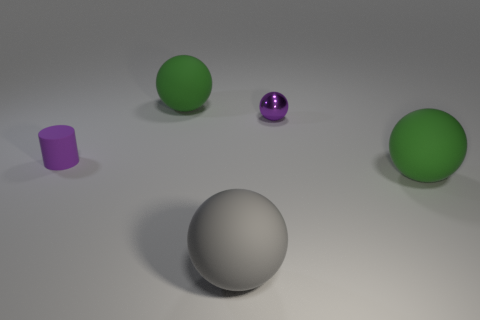Subtract all metal spheres. How many spheres are left? 3 Add 3 tiny purple matte things. How many objects exist? 8 Subtract all purple balls. How many balls are left? 3 Subtract all purple cylinders. How many green balls are left? 2 Subtract all cylinders. How many objects are left? 4 Subtract all blue cylinders. Subtract all yellow cubes. How many cylinders are left? 1 Subtract all big green matte blocks. Subtract all small cylinders. How many objects are left? 4 Add 1 matte cylinders. How many matte cylinders are left? 2 Add 4 big green things. How many big green things exist? 6 Subtract 0 yellow cylinders. How many objects are left? 5 